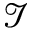Convert formula to latex. <formula><loc_0><loc_0><loc_500><loc_500>\mathcal { I }</formula> 